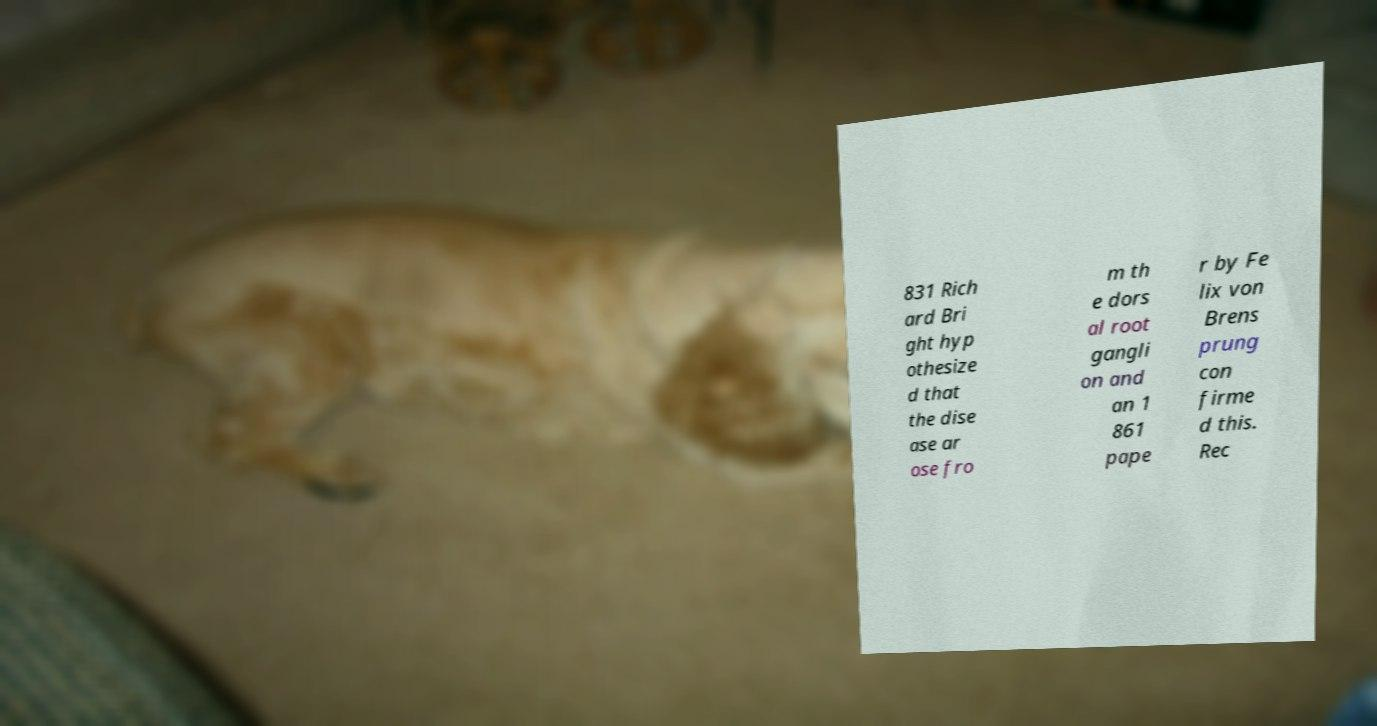I need the written content from this picture converted into text. Can you do that? 831 Rich ard Bri ght hyp othesize d that the dise ase ar ose fro m th e dors al root gangli on and an 1 861 pape r by Fe lix von Brens prung con firme d this. Rec 